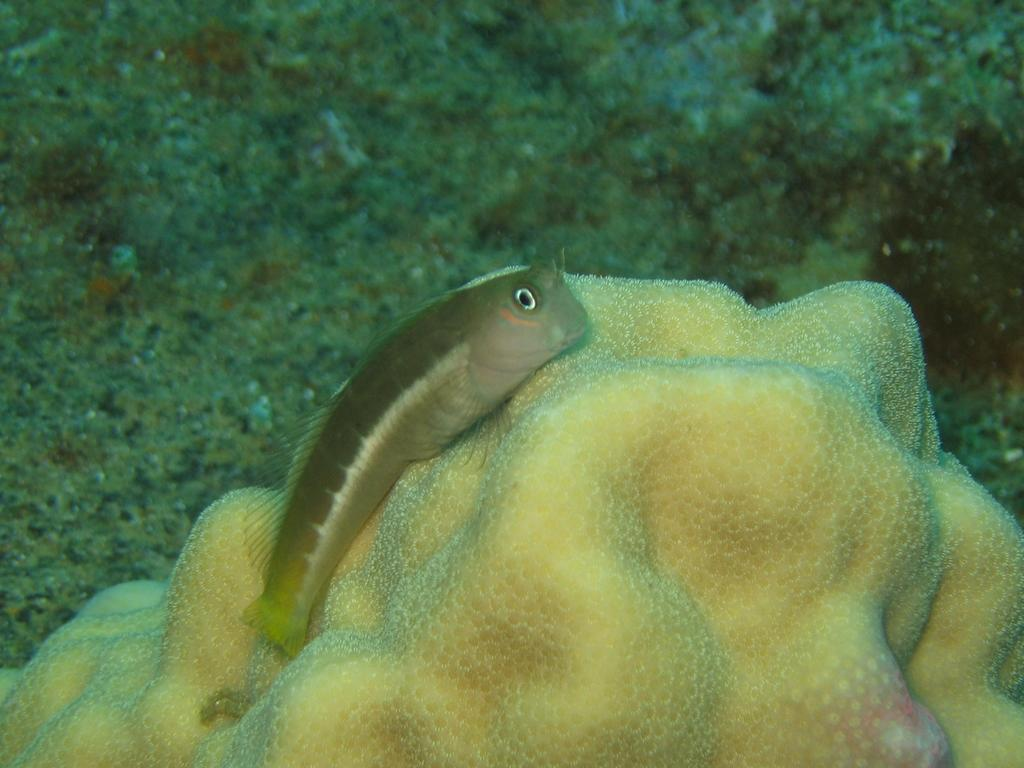What type of environment is shown in the image? The image depicts an underwater environment. Can you identify any living creatures in the image? Yes, there is a fish in the image. What type of cabbage is being sold in the underwater shop in the image? There is no cabbage or shop present in the image; it depicts an underwater environment with a fish. 